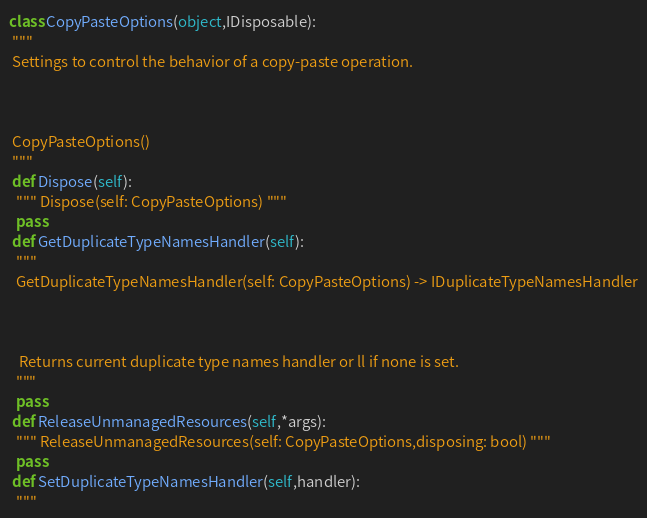<code> <loc_0><loc_0><loc_500><loc_500><_Python_>class CopyPasteOptions(object,IDisposable):
 """
 Settings to control the behavior of a copy-paste operation.

 

 CopyPasteOptions()
 """
 def Dispose(self):
  """ Dispose(self: CopyPasteOptions) """
  pass
 def GetDuplicateTypeNamesHandler(self):
  """
  GetDuplicateTypeNamesHandler(self: CopyPasteOptions) -> IDuplicateTypeNamesHandler

  

   Returns current duplicate type names handler or ll if none is set.
  """
  pass
 def ReleaseUnmanagedResources(self,*args):
  """ ReleaseUnmanagedResources(self: CopyPasteOptions,disposing: bool) """
  pass
 def SetDuplicateTypeNamesHandler(self,handler):
  """</code> 